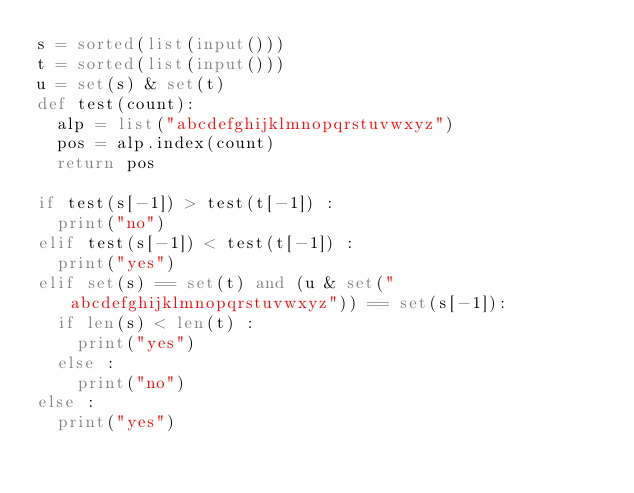<code> <loc_0><loc_0><loc_500><loc_500><_Python_>s = sorted(list(input()))
t = sorted(list(input()))
u = set(s) & set(t)
def test(count):
  alp = list("abcdefghijklmnopqrstuvwxyz")
  pos = alp.index(count)
  return pos

if test(s[-1]) > test(t[-1]) :
  print("no")
elif test(s[-1]) < test(t[-1]) :
  print("yes")
elif set(s) == set(t) and (u & set("abcdefghijklmnopqrstuvwxyz")) == set(s[-1]):
  if len(s) < len(t) :
    print("yes")
  else :
    print("no")
else :
  print("yes")
  </code> 